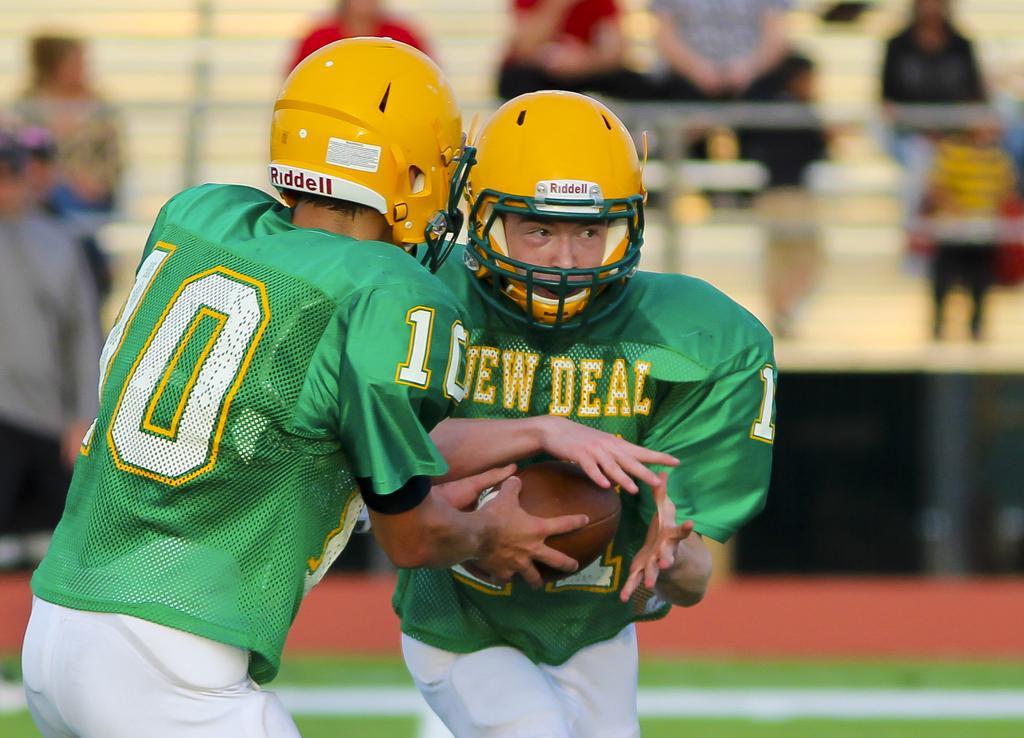How would you summarize this image in a sentence or two? In the picture I can see two men. They are wearing a sport dress and there is a helmet on their heads. I can see a person on the left side is holding a rugby ball in his hands. In the background, I can see a few persons, though their faces are not visible. 